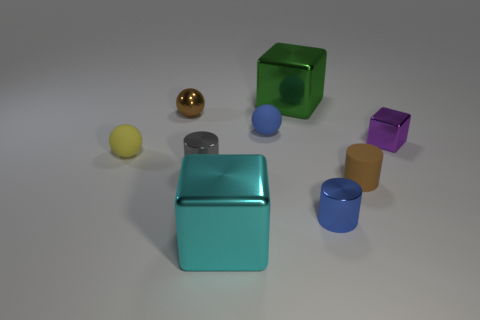Add 1 brown metallic objects. How many objects exist? 10 Subtract all small purple metal cubes. How many cubes are left? 2 Subtract 1 cylinders. How many cylinders are left? 2 Subtract all gray cubes. Subtract all gray balls. How many cubes are left? 3 Subtract all cubes. How many objects are left? 6 Add 2 blue rubber balls. How many blue rubber balls are left? 3 Add 6 blue spheres. How many blue spheres exist? 7 Subtract 1 green blocks. How many objects are left? 8 Subtract all yellow rubber spheres. Subtract all small blocks. How many objects are left? 7 